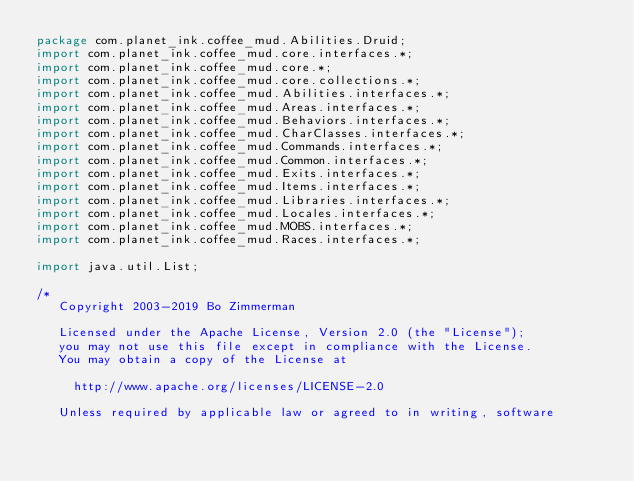Convert code to text. <code><loc_0><loc_0><loc_500><loc_500><_Java_>package com.planet_ink.coffee_mud.Abilities.Druid;
import com.planet_ink.coffee_mud.core.interfaces.*;
import com.planet_ink.coffee_mud.core.*;
import com.planet_ink.coffee_mud.core.collections.*;
import com.planet_ink.coffee_mud.Abilities.interfaces.*;
import com.planet_ink.coffee_mud.Areas.interfaces.*;
import com.planet_ink.coffee_mud.Behaviors.interfaces.*;
import com.planet_ink.coffee_mud.CharClasses.interfaces.*;
import com.planet_ink.coffee_mud.Commands.interfaces.*;
import com.planet_ink.coffee_mud.Common.interfaces.*;
import com.planet_ink.coffee_mud.Exits.interfaces.*;
import com.planet_ink.coffee_mud.Items.interfaces.*;
import com.planet_ink.coffee_mud.Libraries.interfaces.*;
import com.planet_ink.coffee_mud.Locales.interfaces.*;
import com.planet_ink.coffee_mud.MOBS.interfaces.*;
import com.planet_ink.coffee_mud.Races.interfaces.*;

import java.util.List;

/*
   Copyright 2003-2019 Bo Zimmerman

   Licensed under the Apache License, Version 2.0 (the "License");
   you may not use this file except in compliance with the License.
   You may obtain a copy of the License at

	   http://www.apache.org/licenses/LICENSE-2.0

   Unless required by applicable law or agreed to in writing, software</code> 